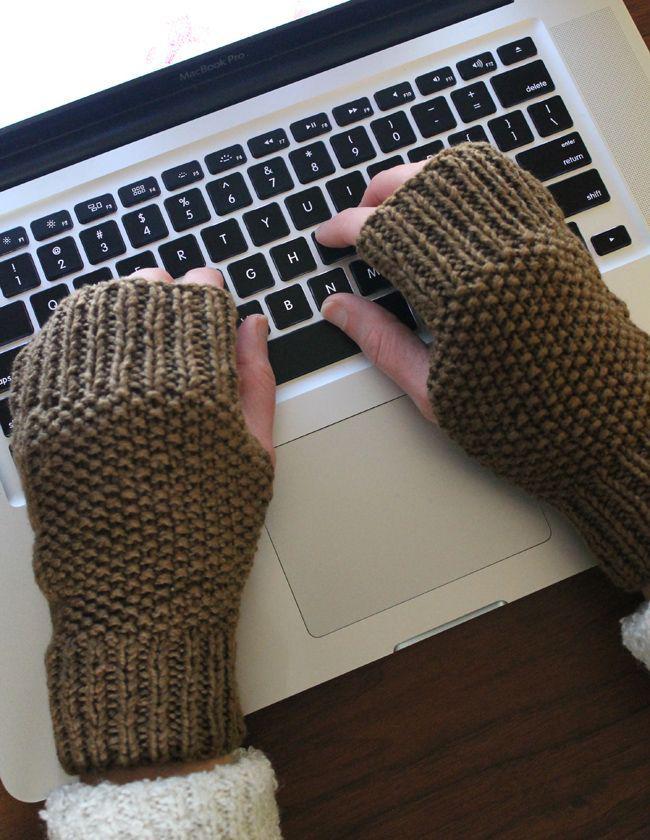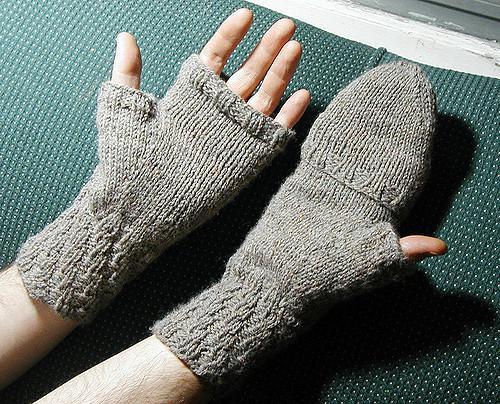The first image is the image on the left, the second image is the image on the right. For the images displayed, is the sentence "There is at least one human hand in the image on the right." factually correct? Answer yes or no. Yes. 